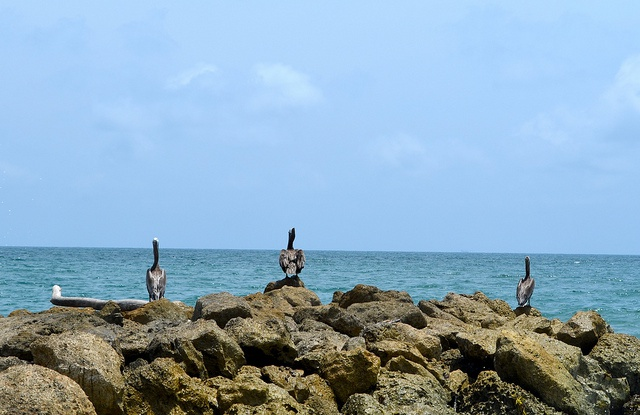Describe the objects in this image and their specific colors. I can see bird in lightblue, gray, black, and darkgray tones, bird in lightblue, black, gray, and darkgray tones, and bird in lightblue, gray, black, darkgray, and blue tones in this image. 